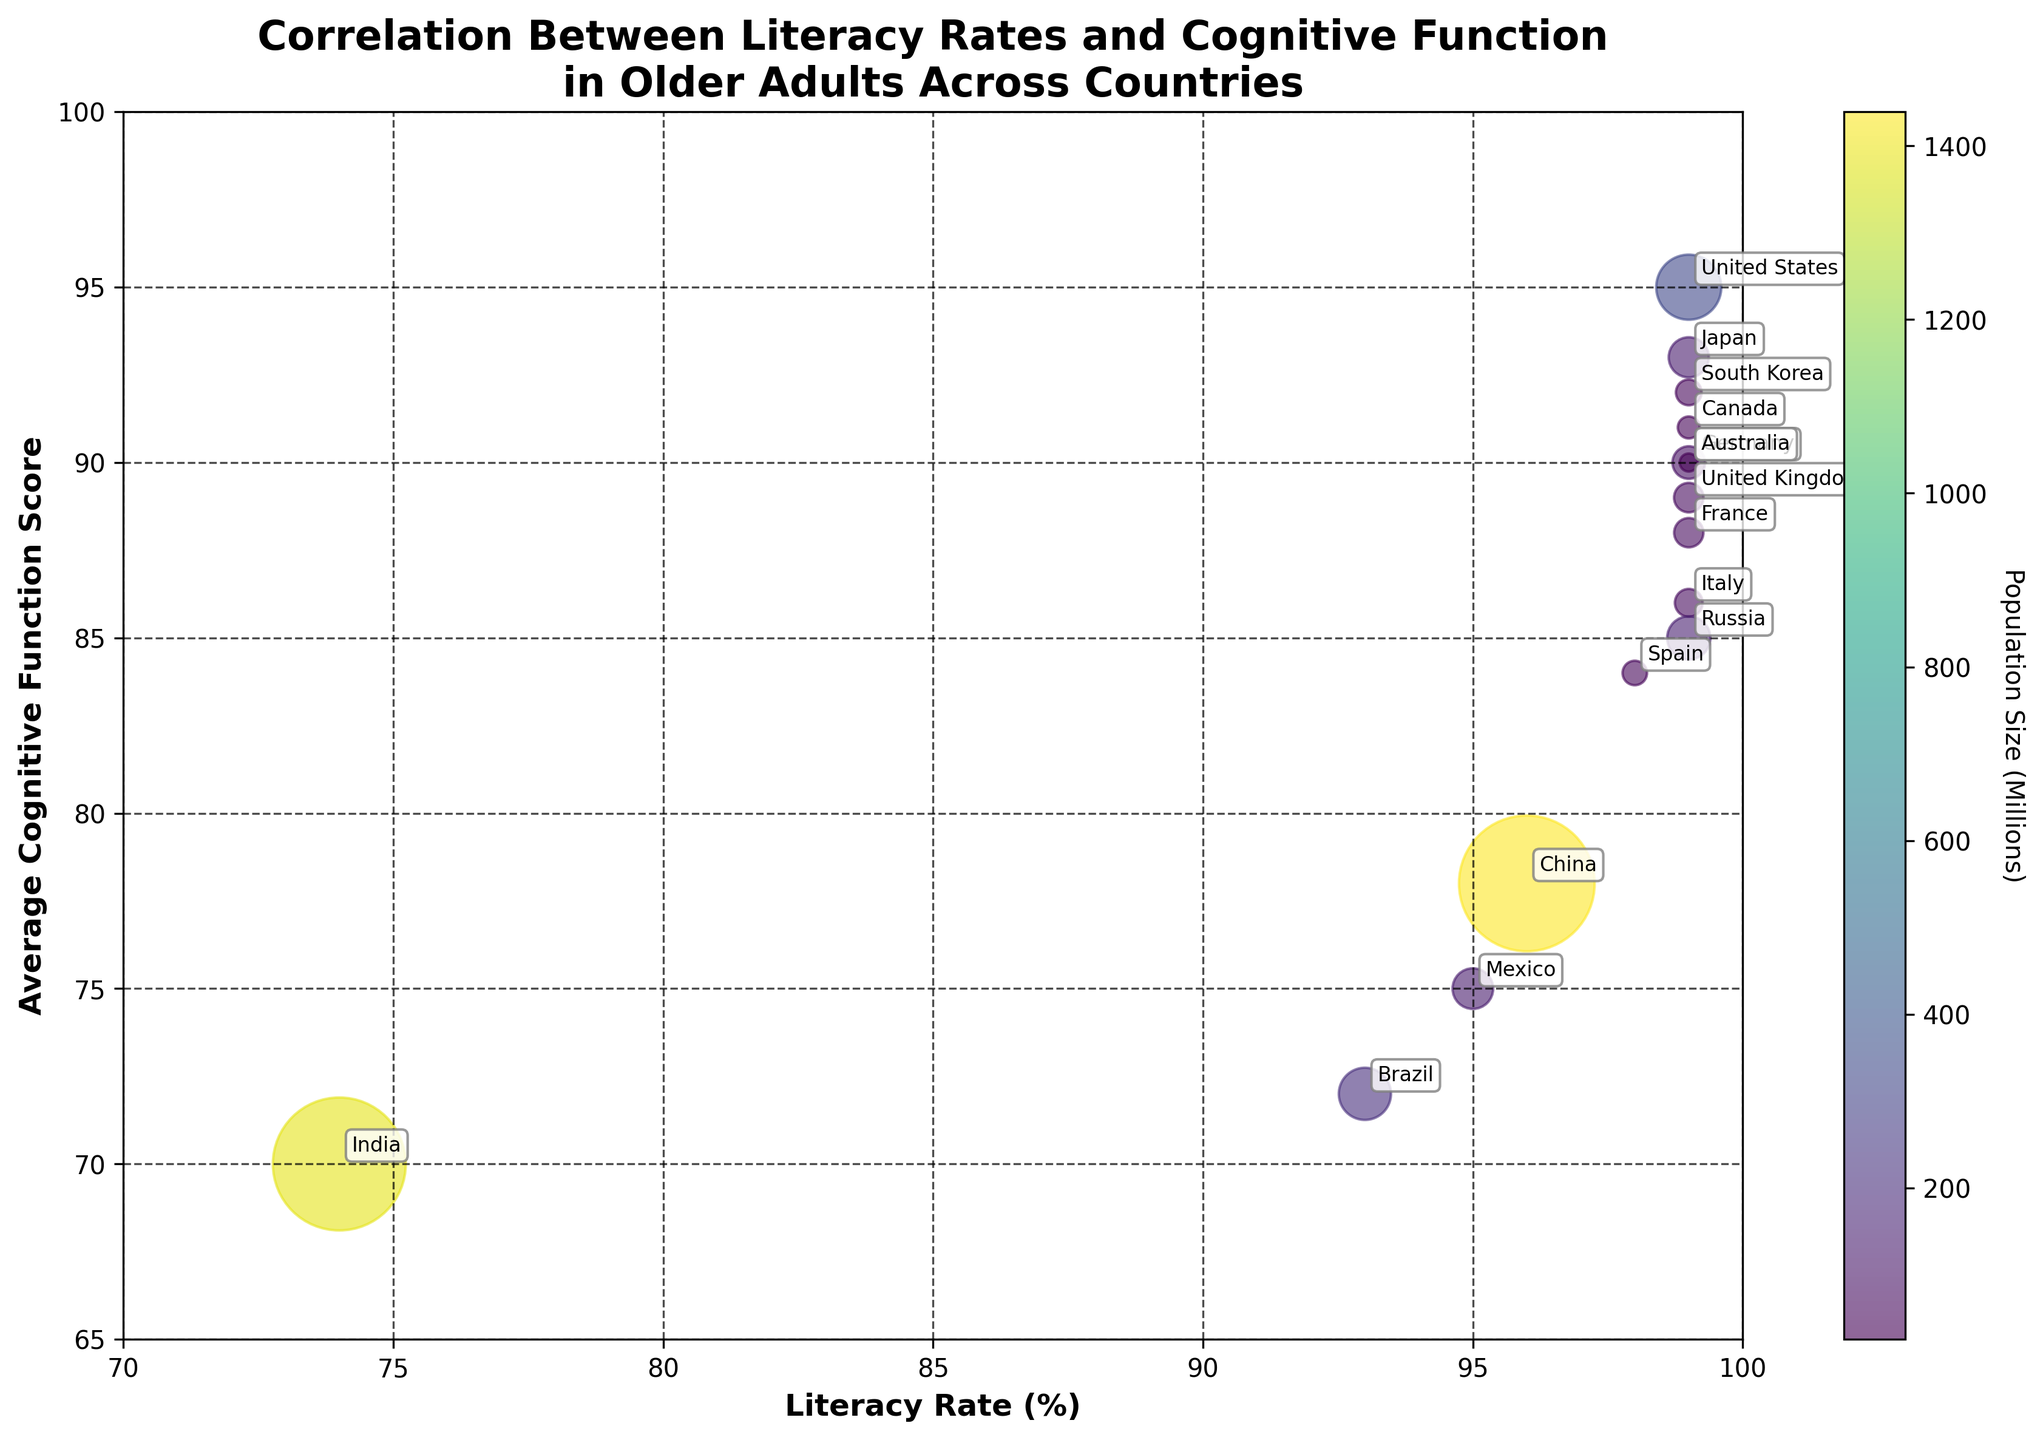What is the title of the plot? The title is typically found at the top of the figure and describes the main theme of the chart. In this plot, the title is "Correlation Between Literacy Rates and Cognitive Function in Older Adults Across Countries."
Answer: Correlation Between Literacy Rates and Cognitive Function in Older Adults Across Countries Which country has the highest literacy rate and what is its cognitive function score? Both the x-axis (Literacy Rate) and y-axis (Cognitive Function) are needed for this question. All countries listed with a 99% literacy rate should be checked for their cognitive function scores. From there, we pick the highest score.
Answer: United States, 95 What is the range of literacy rates shown in the plot? The x-axis represents Literacy Rate and spans from 70 to 100. The minimum value observed in the plotted points is from India (74) and the maximum from several countries (99).
Answer: 74 to 99 Which country has the lowest cognitive function score and what is its literacy rate? The y-axis shows the Average Cognitive Function. Checking for the lowest y-value corresponding to the plotted points will give the answer. India has the lowest score at 70, and its literacy rate is 74.
Answer: India, 74 Compare the cognitive function scores between the countries with the smallest and largest populations. Look for countries with extreme population values. India and China have the largest populations. Comparing their cognitive function scores of India (70) and China (78) gives the answer.
Answer: China has a higher score (78 vs. 70) What is the average cognitive function score of countries with a literacy rate of 99%? Identify the countries with a 99% literacy rate (United States, Japan, Germany, Canada, France, United Kingdom, Italy, South Korea, Australia, Russia). Then, sum their cognitive function scores (95, 93, 90, 91, 88, 89, 86, 92, 90, 85) and divide by the number of such countries (10).
Answer: 89.9 Which country shows a lower cognitive function score despite having a high literacy rate similar to others? Focus on countries with literacy rates close to the maximum (98-99%). Comparing the cognitive function scores, Spain (84) stands out despite having a literacy rate of 98%, lower than others in higher regions.
Answer: Spain Considering the bubble sizes, which country represents the largest population and what does it indicate about its literacy and cognitive function scores? The plot uses bubble size to represent the population size. The largest bubble is China with the largest population. Observing China's bubble position gives its literacy rate (96) and cognitive function score (78).
Answer: China Which countries have the same cognitive function score of 90 and how do their literacy rates compare? Identify the bubbles at the y value of 90. Both Germany, and Australia have a score of 90. Comparing their literacy rates, they both have literacy rates of 99%.
Answer: Germany and Australia What does the color of the bubbles represent and how is it significant? The plot description explains that the color represents population size, and the color bar helps to determine this. This aids in understanding how population size correlates with literacy rate and cognitive function.
Answer: Population size 